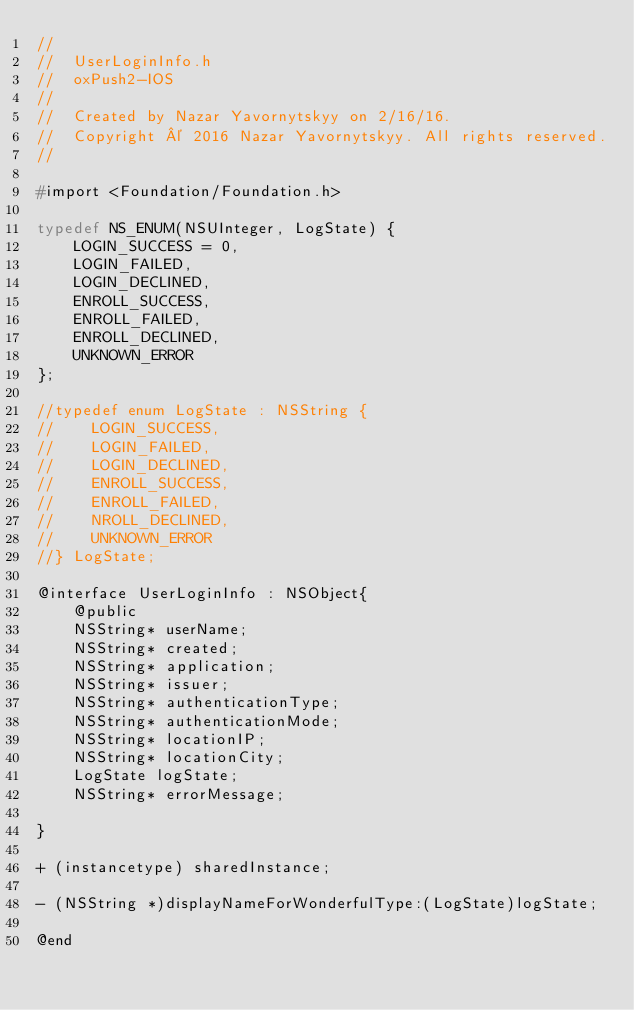Convert code to text. <code><loc_0><loc_0><loc_500><loc_500><_C_>//
//  UserLoginInfo.h
//  oxPush2-IOS
//
//  Created by Nazar Yavornytskyy on 2/16/16.
//  Copyright © 2016 Nazar Yavornytskyy. All rights reserved.
//

#import <Foundation/Foundation.h>

typedef NS_ENUM(NSUInteger, LogState) {
    LOGIN_SUCCESS = 0,
    LOGIN_FAILED,
    LOGIN_DECLINED,
    ENROLL_SUCCESS,
    ENROLL_FAILED,
    ENROLL_DECLINED,
    UNKNOWN_ERROR
};

//typedef enum LogState : NSString {
//    LOGIN_SUCCESS,
//    LOGIN_FAILED,
//    LOGIN_DECLINED,
//    ENROLL_SUCCESS,
//    ENROLL_FAILED,
//    NROLL_DECLINED,
//    UNKNOWN_ERROR
//} LogState;

@interface UserLoginInfo : NSObject{
    @public
    NSString* userName;
    NSString* created;
    NSString* application;
    NSString* issuer;
    NSString* authenticationType;
    NSString* authenticationMode;
    NSString* locationIP;
    NSString* locationCity;
    LogState logState;
    NSString* errorMessage;
    
}
    
+ (instancetype) sharedInstance;
    
- (NSString *)displayNameForWonderfulType:(LogState)logState;

@end
</code> 